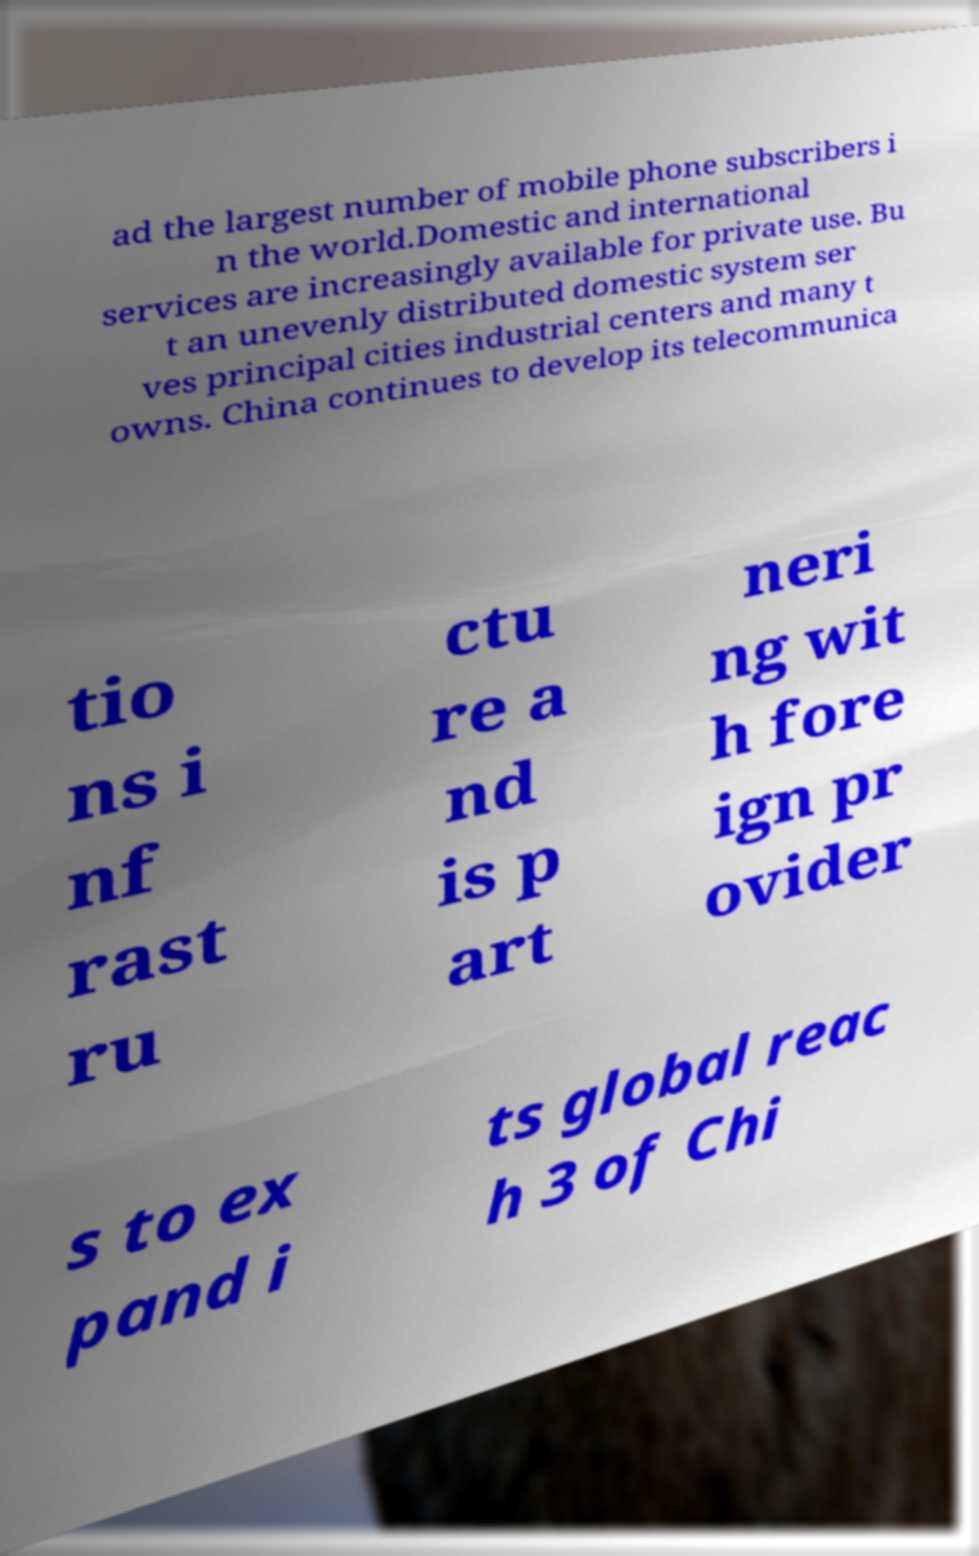Could you assist in decoding the text presented in this image and type it out clearly? ad the largest number of mobile phone subscribers i n the world.Domestic and international services are increasingly available for private use. Bu t an unevenly distributed domestic system ser ves principal cities industrial centers and many t owns. China continues to develop its telecommunica tio ns i nf rast ru ctu re a nd is p art neri ng wit h fore ign pr ovider s to ex pand i ts global reac h 3 of Chi 